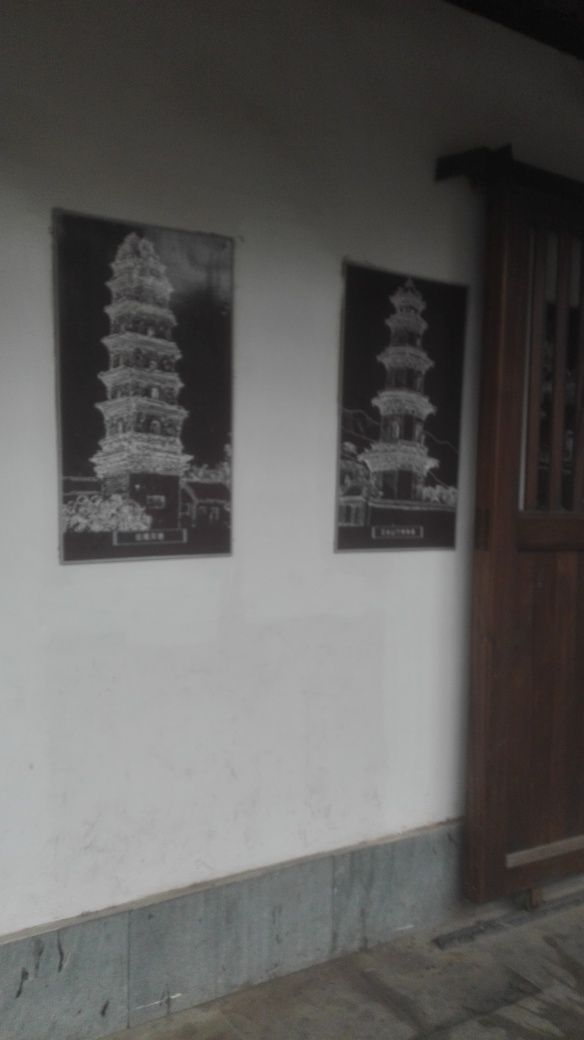Can you tell anything about the location where the picture was taken? Although it's difficult to determine the exact location where the photo was taken, it seems to be an indoor setting, possibly an exhibition space or a hallway, given the presence of framed pictures on a wall next to a wooden door. The floor also appears to have a traditional stone or tile design. 